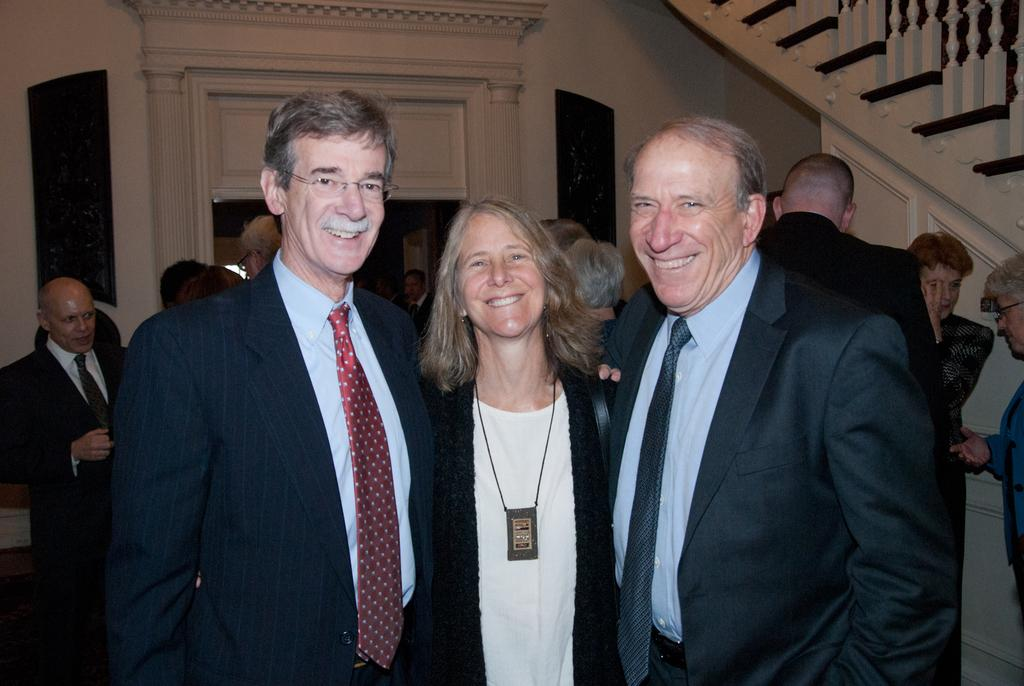How many people are in the image? There are three people in the image. What are the people doing in the image? Three people are standing and smiling. What can be seen in the background of the image? There is a wall, a railing, and frames in the background of the image. What type of condition is required for the people to join the experience in the image? There is no mention of a condition or experience in the image; it simply shows three people standing and smiling. 